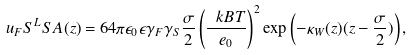<formula> <loc_0><loc_0><loc_500><loc_500>u _ { F } S ^ { L } S A ( z ) = 6 4 \pi \epsilon _ { 0 } \epsilon \gamma _ { F } \gamma _ { S } \frac { \sigma } { 2 } \left ( \frac { \ k B T } { e _ { 0 } } \right ) ^ { 2 } \exp \left ( - \kappa _ { W } ( z ) ( z - \frac { \sigma } { 2 } ) \right ) ,</formula> 